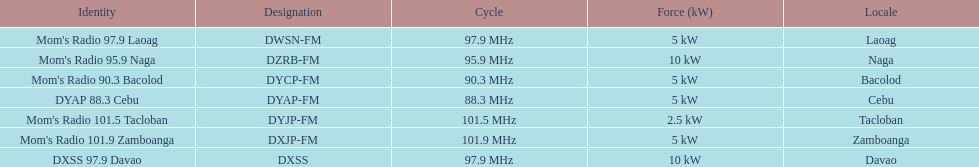Would you mind parsing the complete table? {'header': ['Identity', 'Designation', 'Cycle', 'Force (kW)', 'Locale'], 'rows': [["Mom's Radio 97.9 Laoag", 'DWSN-FM', '97.9\xa0MHz', '5\xa0kW', 'Laoag'], ["Mom's Radio 95.9 Naga", 'DZRB-FM', '95.9\xa0MHz', '10\xa0kW', 'Naga'], ["Mom's Radio 90.3 Bacolod", 'DYCP-FM', '90.3\xa0MHz', '5\xa0kW', 'Bacolod'], ['DYAP 88.3 Cebu', 'DYAP-FM', '88.3\xa0MHz', '5\xa0kW', 'Cebu'], ["Mom's Radio 101.5 Tacloban", 'DYJP-FM', '101.5\xa0MHz', '2.5\xa0kW', 'Tacloban'], ["Mom's Radio 101.9 Zamboanga", 'DXJP-FM', '101.9\xa0MHz', '5\xa0kW', 'Zamboanga'], ['DXSS 97.9 Davao', 'DXSS', '97.9\xa0MHz', '10\xa0kW', 'Davao']]} What is the number of these stations broadcasting at a frequency of greater than 100 mhz? 2. 